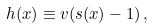Convert formula to latex. <formula><loc_0><loc_0><loc_500><loc_500>h ( x ) \equiv v ( s ( x ) - 1 ) \, ,</formula> 